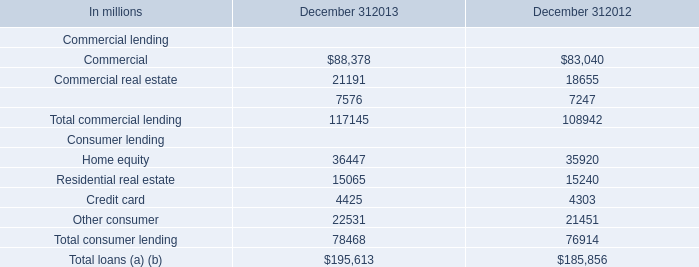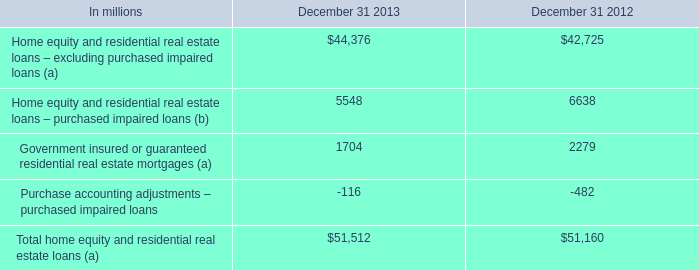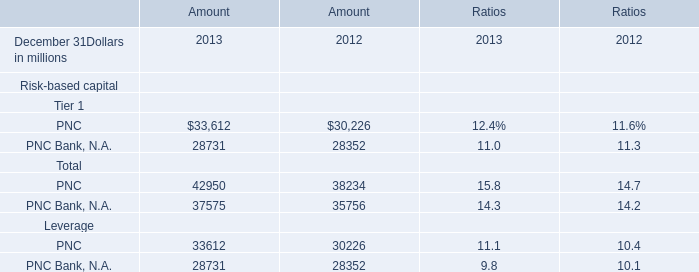What is the sum of PNC of Amount 2013, and Other consumer Consumer lending of December 312012 ? 
Computations: (33612.0 + 21451.0)
Answer: 55063.0. 